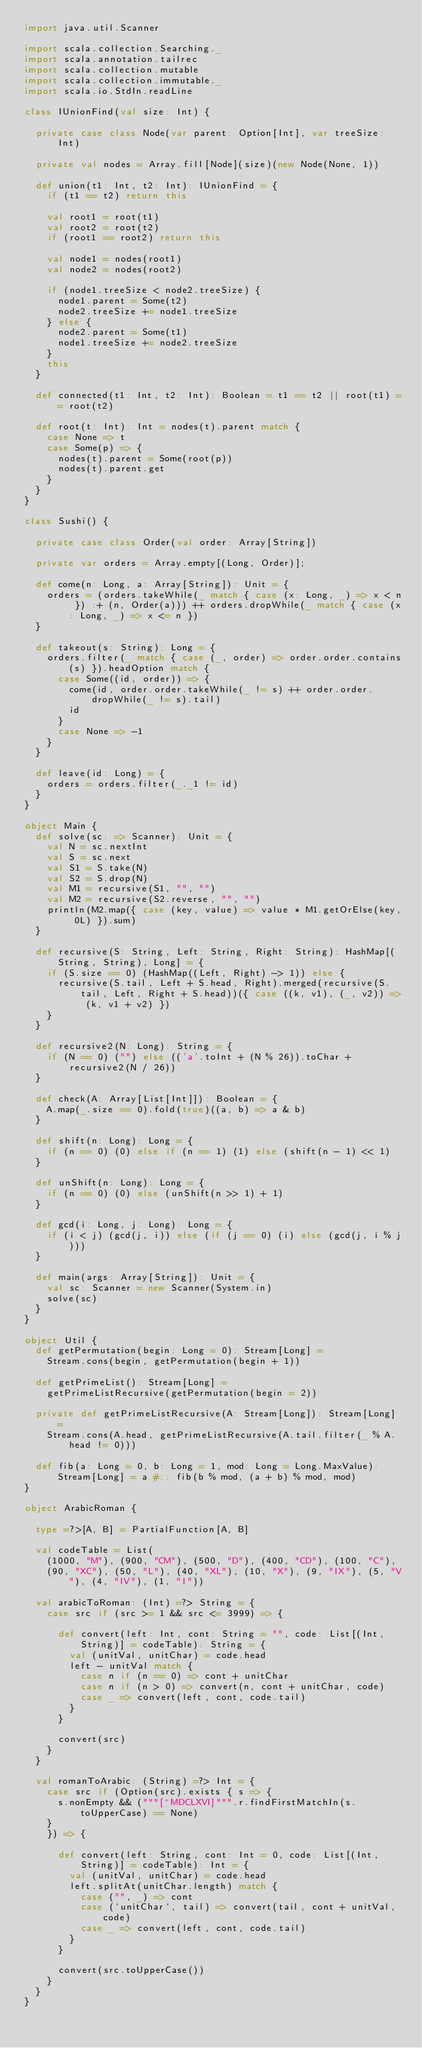Convert code to text. <code><loc_0><loc_0><loc_500><loc_500><_Scala_>import java.util.Scanner

import scala.collection.Searching._
import scala.annotation.tailrec
import scala.collection.mutable
import scala.collection.immutable._
import scala.io.StdIn.readLine

class IUnionFind(val size: Int) {

  private case class Node(var parent: Option[Int], var treeSize: Int)

  private val nodes = Array.fill[Node](size)(new Node(None, 1))

  def union(t1: Int, t2: Int): IUnionFind = {
    if (t1 == t2) return this

    val root1 = root(t1)
    val root2 = root(t2)
    if (root1 == root2) return this

    val node1 = nodes(root1)
    val node2 = nodes(root2)

    if (node1.treeSize < node2.treeSize) {
      node1.parent = Some(t2)
      node2.treeSize += node1.treeSize
    } else {
      node2.parent = Some(t1)
      node1.treeSize += node2.treeSize
    }
    this
  }

  def connected(t1: Int, t2: Int): Boolean = t1 == t2 || root(t1) == root(t2)

  def root(t: Int): Int = nodes(t).parent match {
    case None => t
    case Some(p) => {
      nodes(t).parent = Some(root(p))
      nodes(t).parent.get
    }
  }
}

class Sushi() {

  private case class Order(val order: Array[String])

  private var orders = Array.empty[(Long, Order)];

  def come(n: Long, a: Array[String]): Unit = {
    orders = (orders.takeWhile(_ match { case (x: Long, _) => x < n }) :+ (n, Order(a))) ++ orders.dropWhile(_ match { case (x: Long, _) => x <= n })
  }

  def takeout(s: String): Long = {
    orders.filter(_ match { case (_, order) => order.order.contains(s) }).headOption match {
      case Some((id, order)) => {
        come(id, order.order.takeWhile(_ != s) ++ order.order.dropWhile(_ != s).tail)
        id
      }
      case None => -1
    }
  }

  def leave(id: Long) = {
    orders = orders.filter(_._1 != id)
  }
}

object Main {
  def solve(sc: => Scanner): Unit = {
    val N = sc.nextInt
    val S = sc.next
    val S1 = S.take(N)
    val S2 = S.drop(N)
    val M1 = recursive(S1, "", "")
    val M2 = recursive(S2.reverse, "", "")
    println(M2.map({ case (key, value) => value * M1.getOrElse(key, 0L) }).sum)
  }

  def recursive(S: String, Left: String, Right: String): HashMap[(String, String), Long] = {
    if (S.size == 0) (HashMap((Left, Right) -> 1)) else {
      recursive(S.tail, Left + S.head, Right).merged(recursive(S.tail, Left, Right + S.head))({ case ((k, v1), (_, v2)) => (k, v1 + v2) })
    }
  }

  def recursive2(N: Long): String = {
    if (N == 0) ("") else (('a'.toInt + (N % 26)).toChar + recursive2(N / 26))
  }

  def check(A: Array[List[Int]]): Boolean = {
    A.map(_.size == 0).fold(true)((a, b) => a & b)
  }

  def shift(n: Long): Long = {
    if (n == 0) (0) else if (n == 1) (1) else (shift(n - 1) << 1)
  }

  def unShift(n: Long): Long = {
    if (n == 0) (0) else (unShift(n >> 1) + 1)
  }

  def gcd(i: Long, j: Long): Long = {
    if (i < j) (gcd(j, i)) else (if (j == 0) (i) else (gcd(j, i % j)))
  }

  def main(args: Array[String]): Unit = {
    val sc: Scanner = new Scanner(System.in)
    solve(sc)
  }
}

object Util {
  def getPermutation(begin: Long = 0): Stream[Long] =
    Stream.cons(begin, getPermutation(begin + 1))

  def getPrimeList(): Stream[Long] =
    getPrimeListRecursive(getPermutation(begin = 2))

  private def getPrimeListRecursive(A: Stream[Long]): Stream[Long] =
    Stream.cons(A.head, getPrimeListRecursive(A.tail.filter(_ % A.head != 0)))

  def fib(a: Long = 0, b: Long = 1, mod: Long = Long.MaxValue): Stream[Long] = a #:: fib(b % mod, (a + b) % mod, mod)
}

object ArabicRoman {

  type =?>[A, B] = PartialFunction[A, B]

  val codeTable = List(
    (1000, "M"), (900, "CM"), (500, "D"), (400, "CD"), (100, "C"),
    (90, "XC"), (50, "L"), (40, "XL"), (10, "X"), (9, "IX"), (5, "V"), (4, "IV"), (1, "I"))

  val arabicToRoman: (Int) =?> String = {
    case src if (src >= 1 && src <= 3999) => {

      def convert(left: Int, cont: String = "", code: List[(Int, String)] = codeTable): String = {
        val (unitVal, unitChar) = code.head
        left - unitVal match {
          case n if (n == 0) => cont + unitChar
          case n if (n > 0) => convert(n, cont + unitChar, code)
          case _ => convert(left, cont, code.tail)
        }
      }

      convert(src)
    }
  }

  val romanToArabic: (String) =?> Int = {
    case src if (Option(src).exists { s => {
      s.nonEmpty && ("""[^MDCLXVI]""".r.findFirstMatchIn(s.toUpperCase) == None)
    }
    }) => {

      def convert(left: String, cont: Int = 0, code: List[(Int, String)] = codeTable): Int = {
        val (unitVal, unitChar) = code.head
        left.splitAt(unitChar.length) match {
          case ("", _) => cont
          case (`unitChar`, tail) => convert(tail, cont + unitVal, code)
          case _ => convert(left, cont, code.tail)
        }
      }

      convert(src.toUpperCase())
    }
  }
}
</code> 